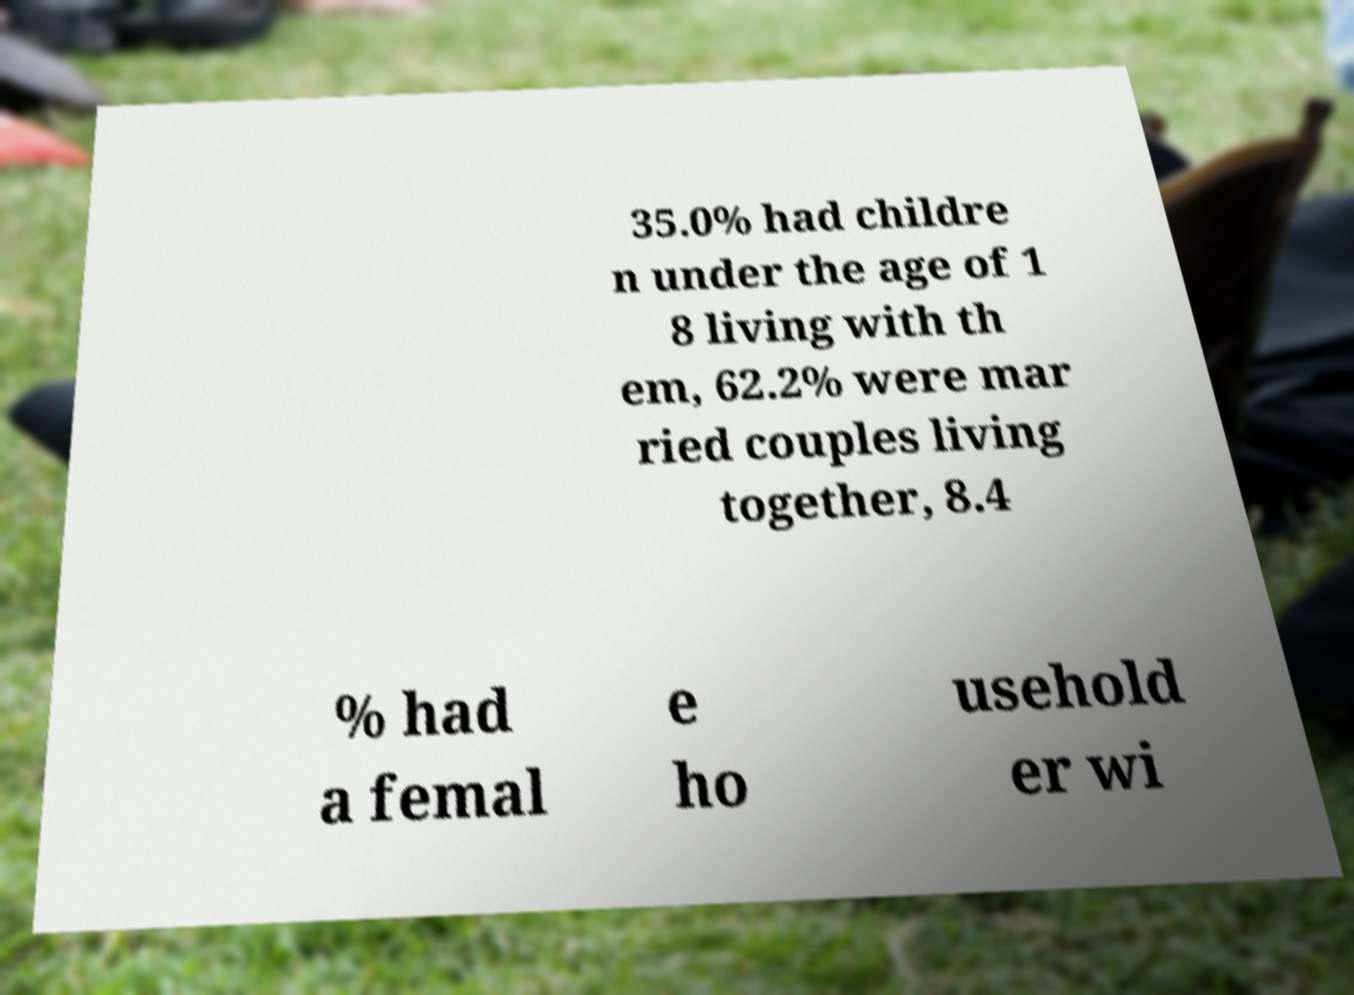Please read and relay the text visible in this image. What does it say? 35.0% had childre n under the age of 1 8 living with th em, 62.2% were mar ried couples living together, 8.4 % had a femal e ho usehold er wi 